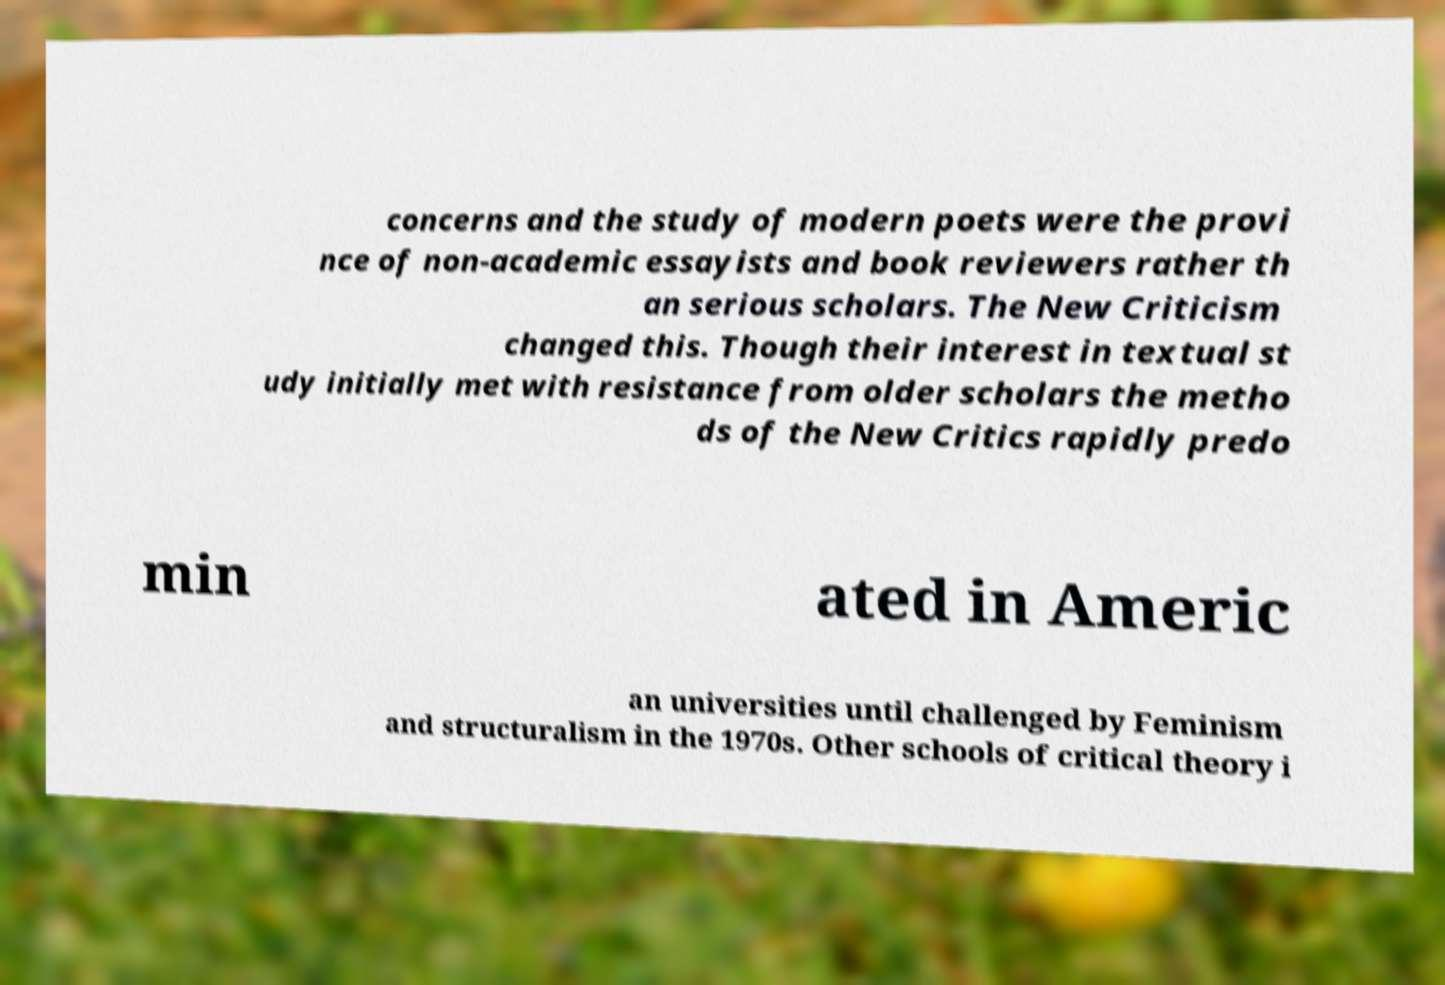I need the written content from this picture converted into text. Can you do that? concerns and the study of modern poets were the provi nce of non-academic essayists and book reviewers rather th an serious scholars. The New Criticism changed this. Though their interest in textual st udy initially met with resistance from older scholars the metho ds of the New Critics rapidly predo min ated in Americ an universities until challenged by Feminism and structuralism in the 1970s. Other schools of critical theory i 